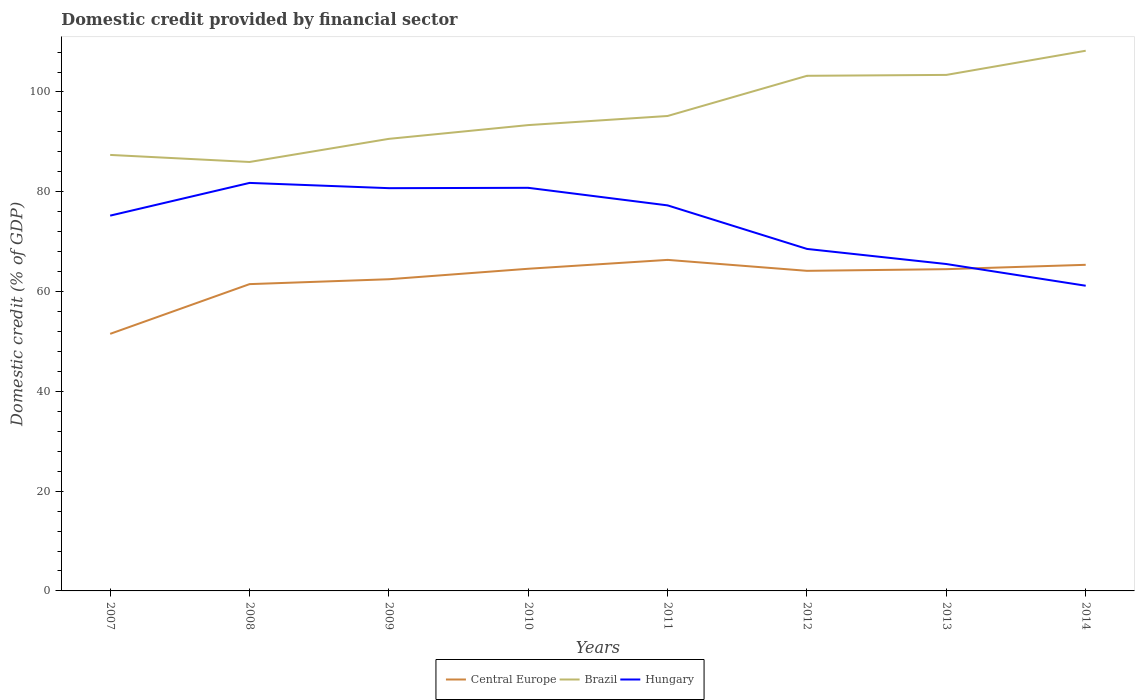How many different coloured lines are there?
Your answer should be very brief. 3. Does the line corresponding to Central Europe intersect with the line corresponding to Hungary?
Provide a succinct answer. Yes. Is the number of lines equal to the number of legend labels?
Give a very brief answer. Yes. Across all years, what is the maximum domestic credit in Brazil?
Offer a terse response. 85.97. What is the total domestic credit in Hungary in the graph?
Your answer should be very brief. 14.05. What is the difference between the highest and the second highest domestic credit in Hungary?
Keep it short and to the point. 20.61. What is the difference between the highest and the lowest domestic credit in Brazil?
Offer a very short reply. 3. Is the domestic credit in Brazil strictly greater than the domestic credit in Hungary over the years?
Keep it short and to the point. No. What is the difference between two consecutive major ticks on the Y-axis?
Your response must be concise. 20. Are the values on the major ticks of Y-axis written in scientific E-notation?
Give a very brief answer. No. Does the graph contain grids?
Your answer should be very brief. No. How many legend labels are there?
Offer a very short reply. 3. What is the title of the graph?
Give a very brief answer. Domestic credit provided by financial sector. What is the label or title of the Y-axis?
Make the answer very short. Domestic credit (% of GDP). What is the Domestic credit (% of GDP) of Central Europe in 2007?
Provide a succinct answer. 51.52. What is the Domestic credit (% of GDP) in Brazil in 2007?
Offer a very short reply. 87.39. What is the Domestic credit (% of GDP) in Hungary in 2007?
Offer a very short reply. 75.22. What is the Domestic credit (% of GDP) in Central Europe in 2008?
Offer a very short reply. 61.49. What is the Domestic credit (% of GDP) in Brazil in 2008?
Ensure brevity in your answer.  85.97. What is the Domestic credit (% of GDP) of Hungary in 2008?
Your answer should be compact. 81.78. What is the Domestic credit (% of GDP) in Central Europe in 2009?
Offer a very short reply. 62.47. What is the Domestic credit (% of GDP) in Brazil in 2009?
Offer a very short reply. 90.61. What is the Domestic credit (% of GDP) of Hungary in 2009?
Offer a very short reply. 80.72. What is the Domestic credit (% of GDP) of Central Europe in 2010?
Provide a succinct answer. 64.57. What is the Domestic credit (% of GDP) in Brazil in 2010?
Offer a very short reply. 93.36. What is the Domestic credit (% of GDP) of Hungary in 2010?
Give a very brief answer. 80.79. What is the Domestic credit (% of GDP) in Central Europe in 2011?
Your answer should be compact. 66.35. What is the Domestic credit (% of GDP) of Brazil in 2011?
Give a very brief answer. 95.19. What is the Domestic credit (% of GDP) of Hungary in 2011?
Your response must be concise. 77.27. What is the Domestic credit (% of GDP) of Central Europe in 2012?
Ensure brevity in your answer.  64.16. What is the Domestic credit (% of GDP) in Brazil in 2012?
Offer a very short reply. 103.24. What is the Domestic credit (% of GDP) in Hungary in 2012?
Your answer should be compact. 68.55. What is the Domestic credit (% of GDP) of Central Europe in 2013?
Offer a very short reply. 64.49. What is the Domestic credit (% of GDP) of Brazil in 2013?
Provide a short and direct response. 103.42. What is the Domestic credit (% of GDP) of Hungary in 2013?
Your response must be concise. 65.52. What is the Domestic credit (% of GDP) in Central Europe in 2014?
Your response must be concise. 65.36. What is the Domestic credit (% of GDP) in Brazil in 2014?
Your answer should be compact. 108.27. What is the Domestic credit (% of GDP) in Hungary in 2014?
Provide a succinct answer. 61.17. Across all years, what is the maximum Domestic credit (% of GDP) in Central Europe?
Keep it short and to the point. 66.35. Across all years, what is the maximum Domestic credit (% of GDP) of Brazil?
Your answer should be very brief. 108.27. Across all years, what is the maximum Domestic credit (% of GDP) of Hungary?
Ensure brevity in your answer.  81.78. Across all years, what is the minimum Domestic credit (% of GDP) in Central Europe?
Your response must be concise. 51.52. Across all years, what is the minimum Domestic credit (% of GDP) of Brazil?
Ensure brevity in your answer.  85.97. Across all years, what is the minimum Domestic credit (% of GDP) in Hungary?
Give a very brief answer. 61.17. What is the total Domestic credit (% of GDP) of Central Europe in the graph?
Give a very brief answer. 500.41. What is the total Domestic credit (% of GDP) of Brazil in the graph?
Your response must be concise. 767.46. What is the total Domestic credit (% of GDP) in Hungary in the graph?
Give a very brief answer. 591.01. What is the difference between the Domestic credit (% of GDP) in Central Europe in 2007 and that in 2008?
Ensure brevity in your answer.  -9.96. What is the difference between the Domestic credit (% of GDP) of Brazil in 2007 and that in 2008?
Make the answer very short. 1.42. What is the difference between the Domestic credit (% of GDP) of Hungary in 2007 and that in 2008?
Provide a succinct answer. -6.56. What is the difference between the Domestic credit (% of GDP) in Central Europe in 2007 and that in 2009?
Your answer should be very brief. -10.95. What is the difference between the Domestic credit (% of GDP) of Brazil in 2007 and that in 2009?
Your response must be concise. -3.22. What is the difference between the Domestic credit (% of GDP) in Hungary in 2007 and that in 2009?
Offer a terse response. -5.51. What is the difference between the Domestic credit (% of GDP) of Central Europe in 2007 and that in 2010?
Give a very brief answer. -13.05. What is the difference between the Domestic credit (% of GDP) in Brazil in 2007 and that in 2010?
Make the answer very short. -5.98. What is the difference between the Domestic credit (% of GDP) of Hungary in 2007 and that in 2010?
Ensure brevity in your answer.  -5.58. What is the difference between the Domestic credit (% of GDP) in Central Europe in 2007 and that in 2011?
Give a very brief answer. -14.82. What is the difference between the Domestic credit (% of GDP) in Brazil in 2007 and that in 2011?
Your answer should be compact. -7.8. What is the difference between the Domestic credit (% of GDP) in Hungary in 2007 and that in 2011?
Your answer should be compact. -2.05. What is the difference between the Domestic credit (% of GDP) in Central Europe in 2007 and that in 2012?
Provide a succinct answer. -12.63. What is the difference between the Domestic credit (% of GDP) in Brazil in 2007 and that in 2012?
Your answer should be very brief. -15.86. What is the difference between the Domestic credit (% of GDP) in Hungary in 2007 and that in 2012?
Provide a short and direct response. 6.67. What is the difference between the Domestic credit (% of GDP) of Central Europe in 2007 and that in 2013?
Your answer should be compact. -12.96. What is the difference between the Domestic credit (% of GDP) in Brazil in 2007 and that in 2013?
Make the answer very short. -16.04. What is the difference between the Domestic credit (% of GDP) in Hungary in 2007 and that in 2013?
Offer a very short reply. 9.7. What is the difference between the Domestic credit (% of GDP) of Central Europe in 2007 and that in 2014?
Ensure brevity in your answer.  -13.84. What is the difference between the Domestic credit (% of GDP) in Brazil in 2007 and that in 2014?
Provide a succinct answer. -20.88. What is the difference between the Domestic credit (% of GDP) of Hungary in 2007 and that in 2014?
Give a very brief answer. 14.05. What is the difference between the Domestic credit (% of GDP) in Central Europe in 2008 and that in 2009?
Your answer should be compact. -0.98. What is the difference between the Domestic credit (% of GDP) of Brazil in 2008 and that in 2009?
Your answer should be compact. -4.64. What is the difference between the Domestic credit (% of GDP) of Hungary in 2008 and that in 2009?
Your answer should be compact. 1.05. What is the difference between the Domestic credit (% of GDP) of Central Europe in 2008 and that in 2010?
Make the answer very short. -3.08. What is the difference between the Domestic credit (% of GDP) of Brazil in 2008 and that in 2010?
Ensure brevity in your answer.  -7.39. What is the difference between the Domestic credit (% of GDP) in Hungary in 2008 and that in 2010?
Your answer should be compact. 0.98. What is the difference between the Domestic credit (% of GDP) of Central Europe in 2008 and that in 2011?
Give a very brief answer. -4.86. What is the difference between the Domestic credit (% of GDP) in Brazil in 2008 and that in 2011?
Keep it short and to the point. -9.22. What is the difference between the Domestic credit (% of GDP) of Hungary in 2008 and that in 2011?
Ensure brevity in your answer.  4.5. What is the difference between the Domestic credit (% of GDP) of Central Europe in 2008 and that in 2012?
Give a very brief answer. -2.67. What is the difference between the Domestic credit (% of GDP) of Brazil in 2008 and that in 2012?
Offer a very short reply. -17.27. What is the difference between the Domestic credit (% of GDP) in Hungary in 2008 and that in 2012?
Your answer should be compact. 13.23. What is the difference between the Domestic credit (% of GDP) of Central Europe in 2008 and that in 2013?
Offer a very short reply. -3. What is the difference between the Domestic credit (% of GDP) in Brazil in 2008 and that in 2013?
Offer a terse response. -17.45. What is the difference between the Domestic credit (% of GDP) in Hungary in 2008 and that in 2013?
Offer a terse response. 16.26. What is the difference between the Domestic credit (% of GDP) of Central Europe in 2008 and that in 2014?
Your answer should be very brief. -3.87. What is the difference between the Domestic credit (% of GDP) of Brazil in 2008 and that in 2014?
Your answer should be very brief. -22.3. What is the difference between the Domestic credit (% of GDP) in Hungary in 2008 and that in 2014?
Keep it short and to the point. 20.61. What is the difference between the Domestic credit (% of GDP) in Central Europe in 2009 and that in 2010?
Keep it short and to the point. -2.1. What is the difference between the Domestic credit (% of GDP) of Brazil in 2009 and that in 2010?
Offer a very short reply. -2.76. What is the difference between the Domestic credit (% of GDP) of Hungary in 2009 and that in 2010?
Your answer should be compact. -0.07. What is the difference between the Domestic credit (% of GDP) of Central Europe in 2009 and that in 2011?
Ensure brevity in your answer.  -3.88. What is the difference between the Domestic credit (% of GDP) of Brazil in 2009 and that in 2011?
Make the answer very short. -4.58. What is the difference between the Domestic credit (% of GDP) of Hungary in 2009 and that in 2011?
Offer a very short reply. 3.45. What is the difference between the Domestic credit (% of GDP) of Central Europe in 2009 and that in 2012?
Ensure brevity in your answer.  -1.69. What is the difference between the Domestic credit (% of GDP) of Brazil in 2009 and that in 2012?
Provide a short and direct response. -12.64. What is the difference between the Domestic credit (% of GDP) of Hungary in 2009 and that in 2012?
Provide a short and direct response. 12.18. What is the difference between the Domestic credit (% of GDP) in Central Europe in 2009 and that in 2013?
Your answer should be compact. -2.02. What is the difference between the Domestic credit (% of GDP) in Brazil in 2009 and that in 2013?
Give a very brief answer. -12.81. What is the difference between the Domestic credit (% of GDP) in Hungary in 2009 and that in 2013?
Provide a short and direct response. 15.21. What is the difference between the Domestic credit (% of GDP) of Central Europe in 2009 and that in 2014?
Offer a terse response. -2.89. What is the difference between the Domestic credit (% of GDP) of Brazil in 2009 and that in 2014?
Your response must be concise. -17.66. What is the difference between the Domestic credit (% of GDP) of Hungary in 2009 and that in 2014?
Your response must be concise. 19.56. What is the difference between the Domestic credit (% of GDP) in Central Europe in 2010 and that in 2011?
Your response must be concise. -1.78. What is the difference between the Domestic credit (% of GDP) of Brazil in 2010 and that in 2011?
Your response must be concise. -1.83. What is the difference between the Domestic credit (% of GDP) in Hungary in 2010 and that in 2011?
Offer a terse response. 3.52. What is the difference between the Domestic credit (% of GDP) in Central Europe in 2010 and that in 2012?
Offer a terse response. 0.42. What is the difference between the Domestic credit (% of GDP) of Brazil in 2010 and that in 2012?
Offer a terse response. -9.88. What is the difference between the Domestic credit (% of GDP) of Hungary in 2010 and that in 2012?
Offer a terse response. 12.25. What is the difference between the Domestic credit (% of GDP) in Central Europe in 2010 and that in 2013?
Your answer should be very brief. 0.08. What is the difference between the Domestic credit (% of GDP) in Brazil in 2010 and that in 2013?
Your answer should be compact. -10.06. What is the difference between the Domestic credit (% of GDP) in Hungary in 2010 and that in 2013?
Ensure brevity in your answer.  15.27. What is the difference between the Domestic credit (% of GDP) in Central Europe in 2010 and that in 2014?
Keep it short and to the point. -0.79. What is the difference between the Domestic credit (% of GDP) in Brazil in 2010 and that in 2014?
Ensure brevity in your answer.  -14.9. What is the difference between the Domestic credit (% of GDP) of Hungary in 2010 and that in 2014?
Provide a short and direct response. 19.63. What is the difference between the Domestic credit (% of GDP) of Central Europe in 2011 and that in 2012?
Keep it short and to the point. 2.19. What is the difference between the Domestic credit (% of GDP) of Brazil in 2011 and that in 2012?
Offer a very short reply. -8.05. What is the difference between the Domestic credit (% of GDP) of Hungary in 2011 and that in 2012?
Ensure brevity in your answer.  8.73. What is the difference between the Domestic credit (% of GDP) of Central Europe in 2011 and that in 2013?
Your answer should be very brief. 1.86. What is the difference between the Domestic credit (% of GDP) in Brazil in 2011 and that in 2013?
Offer a very short reply. -8.23. What is the difference between the Domestic credit (% of GDP) of Hungary in 2011 and that in 2013?
Your response must be concise. 11.75. What is the difference between the Domestic credit (% of GDP) of Brazil in 2011 and that in 2014?
Make the answer very short. -13.08. What is the difference between the Domestic credit (% of GDP) of Hungary in 2011 and that in 2014?
Your response must be concise. 16.11. What is the difference between the Domestic credit (% of GDP) of Central Europe in 2012 and that in 2013?
Offer a very short reply. -0.33. What is the difference between the Domestic credit (% of GDP) in Brazil in 2012 and that in 2013?
Your answer should be very brief. -0.18. What is the difference between the Domestic credit (% of GDP) in Hungary in 2012 and that in 2013?
Offer a terse response. 3.03. What is the difference between the Domestic credit (% of GDP) in Central Europe in 2012 and that in 2014?
Make the answer very short. -1.21. What is the difference between the Domestic credit (% of GDP) in Brazil in 2012 and that in 2014?
Your response must be concise. -5.02. What is the difference between the Domestic credit (% of GDP) in Hungary in 2012 and that in 2014?
Your response must be concise. 7.38. What is the difference between the Domestic credit (% of GDP) in Central Europe in 2013 and that in 2014?
Your response must be concise. -0.87. What is the difference between the Domestic credit (% of GDP) in Brazil in 2013 and that in 2014?
Offer a very short reply. -4.85. What is the difference between the Domestic credit (% of GDP) of Hungary in 2013 and that in 2014?
Ensure brevity in your answer.  4.35. What is the difference between the Domestic credit (% of GDP) in Central Europe in 2007 and the Domestic credit (% of GDP) in Brazil in 2008?
Ensure brevity in your answer.  -34.45. What is the difference between the Domestic credit (% of GDP) of Central Europe in 2007 and the Domestic credit (% of GDP) of Hungary in 2008?
Offer a terse response. -30.25. What is the difference between the Domestic credit (% of GDP) in Brazil in 2007 and the Domestic credit (% of GDP) in Hungary in 2008?
Your response must be concise. 5.61. What is the difference between the Domestic credit (% of GDP) in Central Europe in 2007 and the Domestic credit (% of GDP) in Brazil in 2009?
Ensure brevity in your answer.  -39.08. What is the difference between the Domestic credit (% of GDP) of Central Europe in 2007 and the Domestic credit (% of GDP) of Hungary in 2009?
Your response must be concise. -29.2. What is the difference between the Domestic credit (% of GDP) in Brazil in 2007 and the Domestic credit (% of GDP) in Hungary in 2009?
Ensure brevity in your answer.  6.66. What is the difference between the Domestic credit (% of GDP) of Central Europe in 2007 and the Domestic credit (% of GDP) of Brazil in 2010?
Provide a succinct answer. -41.84. What is the difference between the Domestic credit (% of GDP) of Central Europe in 2007 and the Domestic credit (% of GDP) of Hungary in 2010?
Keep it short and to the point. -29.27. What is the difference between the Domestic credit (% of GDP) of Brazil in 2007 and the Domestic credit (% of GDP) of Hungary in 2010?
Your answer should be very brief. 6.59. What is the difference between the Domestic credit (% of GDP) in Central Europe in 2007 and the Domestic credit (% of GDP) in Brazil in 2011?
Ensure brevity in your answer.  -43.67. What is the difference between the Domestic credit (% of GDP) of Central Europe in 2007 and the Domestic credit (% of GDP) of Hungary in 2011?
Offer a very short reply. -25.75. What is the difference between the Domestic credit (% of GDP) of Brazil in 2007 and the Domestic credit (% of GDP) of Hungary in 2011?
Your response must be concise. 10.12. What is the difference between the Domestic credit (% of GDP) of Central Europe in 2007 and the Domestic credit (% of GDP) of Brazil in 2012?
Your response must be concise. -51.72. What is the difference between the Domestic credit (% of GDP) in Central Europe in 2007 and the Domestic credit (% of GDP) in Hungary in 2012?
Your answer should be very brief. -17.02. What is the difference between the Domestic credit (% of GDP) of Brazil in 2007 and the Domestic credit (% of GDP) of Hungary in 2012?
Provide a succinct answer. 18.84. What is the difference between the Domestic credit (% of GDP) in Central Europe in 2007 and the Domestic credit (% of GDP) in Brazil in 2013?
Offer a terse response. -51.9. What is the difference between the Domestic credit (% of GDP) of Central Europe in 2007 and the Domestic credit (% of GDP) of Hungary in 2013?
Your response must be concise. -13.99. What is the difference between the Domestic credit (% of GDP) of Brazil in 2007 and the Domestic credit (% of GDP) of Hungary in 2013?
Your response must be concise. 21.87. What is the difference between the Domestic credit (% of GDP) of Central Europe in 2007 and the Domestic credit (% of GDP) of Brazil in 2014?
Keep it short and to the point. -56.74. What is the difference between the Domestic credit (% of GDP) in Central Europe in 2007 and the Domestic credit (% of GDP) in Hungary in 2014?
Your response must be concise. -9.64. What is the difference between the Domestic credit (% of GDP) in Brazil in 2007 and the Domestic credit (% of GDP) in Hungary in 2014?
Keep it short and to the point. 26.22. What is the difference between the Domestic credit (% of GDP) in Central Europe in 2008 and the Domestic credit (% of GDP) in Brazil in 2009?
Your answer should be compact. -29.12. What is the difference between the Domestic credit (% of GDP) in Central Europe in 2008 and the Domestic credit (% of GDP) in Hungary in 2009?
Keep it short and to the point. -19.23. What is the difference between the Domestic credit (% of GDP) of Brazil in 2008 and the Domestic credit (% of GDP) of Hungary in 2009?
Make the answer very short. 5.25. What is the difference between the Domestic credit (% of GDP) of Central Europe in 2008 and the Domestic credit (% of GDP) of Brazil in 2010?
Make the answer very short. -31.88. What is the difference between the Domestic credit (% of GDP) of Central Europe in 2008 and the Domestic credit (% of GDP) of Hungary in 2010?
Give a very brief answer. -19.3. What is the difference between the Domestic credit (% of GDP) in Brazil in 2008 and the Domestic credit (% of GDP) in Hungary in 2010?
Your response must be concise. 5.18. What is the difference between the Domestic credit (% of GDP) in Central Europe in 2008 and the Domestic credit (% of GDP) in Brazil in 2011?
Give a very brief answer. -33.7. What is the difference between the Domestic credit (% of GDP) of Central Europe in 2008 and the Domestic credit (% of GDP) of Hungary in 2011?
Provide a succinct answer. -15.78. What is the difference between the Domestic credit (% of GDP) in Brazil in 2008 and the Domestic credit (% of GDP) in Hungary in 2011?
Keep it short and to the point. 8.7. What is the difference between the Domestic credit (% of GDP) in Central Europe in 2008 and the Domestic credit (% of GDP) in Brazil in 2012?
Make the answer very short. -41.76. What is the difference between the Domestic credit (% of GDP) of Central Europe in 2008 and the Domestic credit (% of GDP) of Hungary in 2012?
Provide a succinct answer. -7.06. What is the difference between the Domestic credit (% of GDP) in Brazil in 2008 and the Domestic credit (% of GDP) in Hungary in 2012?
Provide a short and direct response. 17.43. What is the difference between the Domestic credit (% of GDP) in Central Europe in 2008 and the Domestic credit (% of GDP) in Brazil in 2013?
Ensure brevity in your answer.  -41.93. What is the difference between the Domestic credit (% of GDP) in Central Europe in 2008 and the Domestic credit (% of GDP) in Hungary in 2013?
Offer a terse response. -4.03. What is the difference between the Domestic credit (% of GDP) in Brazil in 2008 and the Domestic credit (% of GDP) in Hungary in 2013?
Your response must be concise. 20.45. What is the difference between the Domestic credit (% of GDP) of Central Europe in 2008 and the Domestic credit (% of GDP) of Brazil in 2014?
Provide a short and direct response. -46.78. What is the difference between the Domestic credit (% of GDP) of Central Europe in 2008 and the Domestic credit (% of GDP) of Hungary in 2014?
Offer a very short reply. 0.32. What is the difference between the Domestic credit (% of GDP) of Brazil in 2008 and the Domestic credit (% of GDP) of Hungary in 2014?
Make the answer very short. 24.8. What is the difference between the Domestic credit (% of GDP) in Central Europe in 2009 and the Domestic credit (% of GDP) in Brazil in 2010?
Keep it short and to the point. -30.89. What is the difference between the Domestic credit (% of GDP) of Central Europe in 2009 and the Domestic credit (% of GDP) of Hungary in 2010?
Your answer should be very brief. -18.32. What is the difference between the Domestic credit (% of GDP) in Brazil in 2009 and the Domestic credit (% of GDP) in Hungary in 2010?
Your answer should be compact. 9.81. What is the difference between the Domestic credit (% of GDP) of Central Europe in 2009 and the Domestic credit (% of GDP) of Brazil in 2011?
Provide a short and direct response. -32.72. What is the difference between the Domestic credit (% of GDP) of Central Europe in 2009 and the Domestic credit (% of GDP) of Hungary in 2011?
Ensure brevity in your answer.  -14.8. What is the difference between the Domestic credit (% of GDP) of Brazil in 2009 and the Domestic credit (% of GDP) of Hungary in 2011?
Provide a succinct answer. 13.34. What is the difference between the Domestic credit (% of GDP) of Central Europe in 2009 and the Domestic credit (% of GDP) of Brazil in 2012?
Give a very brief answer. -40.77. What is the difference between the Domestic credit (% of GDP) in Central Europe in 2009 and the Domestic credit (% of GDP) in Hungary in 2012?
Offer a terse response. -6.08. What is the difference between the Domestic credit (% of GDP) of Brazil in 2009 and the Domestic credit (% of GDP) of Hungary in 2012?
Your answer should be compact. 22.06. What is the difference between the Domestic credit (% of GDP) of Central Europe in 2009 and the Domestic credit (% of GDP) of Brazil in 2013?
Your response must be concise. -40.95. What is the difference between the Domestic credit (% of GDP) in Central Europe in 2009 and the Domestic credit (% of GDP) in Hungary in 2013?
Your response must be concise. -3.05. What is the difference between the Domestic credit (% of GDP) of Brazil in 2009 and the Domestic credit (% of GDP) of Hungary in 2013?
Your answer should be very brief. 25.09. What is the difference between the Domestic credit (% of GDP) of Central Europe in 2009 and the Domestic credit (% of GDP) of Brazil in 2014?
Offer a very short reply. -45.8. What is the difference between the Domestic credit (% of GDP) of Central Europe in 2009 and the Domestic credit (% of GDP) of Hungary in 2014?
Make the answer very short. 1.3. What is the difference between the Domestic credit (% of GDP) of Brazil in 2009 and the Domestic credit (% of GDP) of Hungary in 2014?
Provide a short and direct response. 29.44. What is the difference between the Domestic credit (% of GDP) in Central Europe in 2010 and the Domestic credit (% of GDP) in Brazil in 2011?
Keep it short and to the point. -30.62. What is the difference between the Domestic credit (% of GDP) in Central Europe in 2010 and the Domestic credit (% of GDP) in Hungary in 2011?
Your answer should be very brief. -12.7. What is the difference between the Domestic credit (% of GDP) of Brazil in 2010 and the Domestic credit (% of GDP) of Hungary in 2011?
Keep it short and to the point. 16.09. What is the difference between the Domestic credit (% of GDP) in Central Europe in 2010 and the Domestic credit (% of GDP) in Brazil in 2012?
Keep it short and to the point. -38.67. What is the difference between the Domestic credit (% of GDP) in Central Europe in 2010 and the Domestic credit (% of GDP) in Hungary in 2012?
Keep it short and to the point. -3.97. What is the difference between the Domestic credit (% of GDP) of Brazil in 2010 and the Domestic credit (% of GDP) of Hungary in 2012?
Make the answer very short. 24.82. What is the difference between the Domestic credit (% of GDP) of Central Europe in 2010 and the Domestic credit (% of GDP) of Brazil in 2013?
Make the answer very short. -38.85. What is the difference between the Domestic credit (% of GDP) of Central Europe in 2010 and the Domestic credit (% of GDP) of Hungary in 2013?
Make the answer very short. -0.95. What is the difference between the Domestic credit (% of GDP) of Brazil in 2010 and the Domestic credit (% of GDP) of Hungary in 2013?
Your answer should be very brief. 27.85. What is the difference between the Domestic credit (% of GDP) in Central Europe in 2010 and the Domestic credit (% of GDP) in Brazil in 2014?
Your response must be concise. -43.7. What is the difference between the Domestic credit (% of GDP) in Central Europe in 2010 and the Domestic credit (% of GDP) in Hungary in 2014?
Offer a terse response. 3.4. What is the difference between the Domestic credit (% of GDP) of Brazil in 2010 and the Domestic credit (% of GDP) of Hungary in 2014?
Provide a succinct answer. 32.2. What is the difference between the Domestic credit (% of GDP) in Central Europe in 2011 and the Domestic credit (% of GDP) in Brazil in 2012?
Your response must be concise. -36.9. What is the difference between the Domestic credit (% of GDP) in Central Europe in 2011 and the Domestic credit (% of GDP) in Hungary in 2012?
Your answer should be very brief. -2.2. What is the difference between the Domestic credit (% of GDP) in Brazil in 2011 and the Domestic credit (% of GDP) in Hungary in 2012?
Offer a very short reply. 26.65. What is the difference between the Domestic credit (% of GDP) of Central Europe in 2011 and the Domestic credit (% of GDP) of Brazil in 2013?
Provide a short and direct response. -37.07. What is the difference between the Domestic credit (% of GDP) in Central Europe in 2011 and the Domestic credit (% of GDP) in Hungary in 2013?
Your answer should be very brief. 0.83. What is the difference between the Domestic credit (% of GDP) of Brazil in 2011 and the Domestic credit (% of GDP) of Hungary in 2013?
Make the answer very short. 29.67. What is the difference between the Domestic credit (% of GDP) in Central Europe in 2011 and the Domestic credit (% of GDP) in Brazil in 2014?
Offer a very short reply. -41.92. What is the difference between the Domestic credit (% of GDP) in Central Europe in 2011 and the Domestic credit (% of GDP) in Hungary in 2014?
Provide a succinct answer. 5.18. What is the difference between the Domestic credit (% of GDP) in Brazil in 2011 and the Domestic credit (% of GDP) in Hungary in 2014?
Offer a terse response. 34.02. What is the difference between the Domestic credit (% of GDP) of Central Europe in 2012 and the Domestic credit (% of GDP) of Brazil in 2013?
Ensure brevity in your answer.  -39.27. What is the difference between the Domestic credit (% of GDP) in Central Europe in 2012 and the Domestic credit (% of GDP) in Hungary in 2013?
Keep it short and to the point. -1.36. What is the difference between the Domestic credit (% of GDP) in Brazil in 2012 and the Domestic credit (% of GDP) in Hungary in 2013?
Give a very brief answer. 37.73. What is the difference between the Domestic credit (% of GDP) in Central Europe in 2012 and the Domestic credit (% of GDP) in Brazil in 2014?
Ensure brevity in your answer.  -44.11. What is the difference between the Domestic credit (% of GDP) in Central Europe in 2012 and the Domestic credit (% of GDP) in Hungary in 2014?
Offer a terse response. 2.99. What is the difference between the Domestic credit (% of GDP) of Brazil in 2012 and the Domestic credit (% of GDP) of Hungary in 2014?
Keep it short and to the point. 42.08. What is the difference between the Domestic credit (% of GDP) of Central Europe in 2013 and the Domestic credit (% of GDP) of Brazil in 2014?
Provide a short and direct response. -43.78. What is the difference between the Domestic credit (% of GDP) in Central Europe in 2013 and the Domestic credit (% of GDP) in Hungary in 2014?
Your answer should be very brief. 3.32. What is the difference between the Domestic credit (% of GDP) of Brazil in 2013 and the Domestic credit (% of GDP) of Hungary in 2014?
Give a very brief answer. 42.26. What is the average Domestic credit (% of GDP) in Central Europe per year?
Provide a succinct answer. 62.55. What is the average Domestic credit (% of GDP) of Brazil per year?
Your answer should be very brief. 95.93. What is the average Domestic credit (% of GDP) in Hungary per year?
Your answer should be compact. 73.88. In the year 2007, what is the difference between the Domestic credit (% of GDP) in Central Europe and Domestic credit (% of GDP) in Brazil?
Offer a very short reply. -35.86. In the year 2007, what is the difference between the Domestic credit (% of GDP) of Central Europe and Domestic credit (% of GDP) of Hungary?
Offer a very short reply. -23.69. In the year 2007, what is the difference between the Domestic credit (% of GDP) of Brazil and Domestic credit (% of GDP) of Hungary?
Keep it short and to the point. 12.17. In the year 2008, what is the difference between the Domestic credit (% of GDP) of Central Europe and Domestic credit (% of GDP) of Brazil?
Offer a terse response. -24.48. In the year 2008, what is the difference between the Domestic credit (% of GDP) of Central Europe and Domestic credit (% of GDP) of Hungary?
Provide a short and direct response. -20.29. In the year 2008, what is the difference between the Domestic credit (% of GDP) in Brazil and Domestic credit (% of GDP) in Hungary?
Provide a short and direct response. 4.2. In the year 2009, what is the difference between the Domestic credit (% of GDP) of Central Europe and Domestic credit (% of GDP) of Brazil?
Your response must be concise. -28.14. In the year 2009, what is the difference between the Domestic credit (% of GDP) of Central Europe and Domestic credit (% of GDP) of Hungary?
Provide a short and direct response. -18.25. In the year 2009, what is the difference between the Domestic credit (% of GDP) of Brazil and Domestic credit (% of GDP) of Hungary?
Offer a very short reply. 9.88. In the year 2010, what is the difference between the Domestic credit (% of GDP) of Central Europe and Domestic credit (% of GDP) of Brazil?
Provide a short and direct response. -28.79. In the year 2010, what is the difference between the Domestic credit (% of GDP) of Central Europe and Domestic credit (% of GDP) of Hungary?
Offer a very short reply. -16.22. In the year 2010, what is the difference between the Domestic credit (% of GDP) in Brazil and Domestic credit (% of GDP) in Hungary?
Offer a very short reply. 12.57. In the year 2011, what is the difference between the Domestic credit (% of GDP) in Central Europe and Domestic credit (% of GDP) in Brazil?
Your response must be concise. -28.84. In the year 2011, what is the difference between the Domestic credit (% of GDP) in Central Europe and Domestic credit (% of GDP) in Hungary?
Offer a terse response. -10.92. In the year 2011, what is the difference between the Domestic credit (% of GDP) in Brazil and Domestic credit (% of GDP) in Hungary?
Your answer should be very brief. 17.92. In the year 2012, what is the difference between the Domestic credit (% of GDP) of Central Europe and Domestic credit (% of GDP) of Brazil?
Offer a terse response. -39.09. In the year 2012, what is the difference between the Domestic credit (% of GDP) of Central Europe and Domestic credit (% of GDP) of Hungary?
Your answer should be compact. -4.39. In the year 2012, what is the difference between the Domestic credit (% of GDP) in Brazil and Domestic credit (% of GDP) in Hungary?
Offer a very short reply. 34.7. In the year 2013, what is the difference between the Domestic credit (% of GDP) in Central Europe and Domestic credit (% of GDP) in Brazil?
Your response must be concise. -38.94. In the year 2013, what is the difference between the Domestic credit (% of GDP) of Central Europe and Domestic credit (% of GDP) of Hungary?
Offer a terse response. -1.03. In the year 2013, what is the difference between the Domestic credit (% of GDP) of Brazil and Domestic credit (% of GDP) of Hungary?
Offer a very short reply. 37.9. In the year 2014, what is the difference between the Domestic credit (% of GDP) of Central Europe and Domestic credit (% of GDP) of Brazil?
Offer a terse response. -42.91. In the year 2014, what is the difference between the Domestic credit (% of GDP) of Central Europe and Domestic credit (% of GDP) of Hungary?
Keep it short and to the point. 4.19. In the year 2014, what is the difference between the Domestic credit (% of GDP) of Brazil and Domestic credit (% of GDP) of Hungary?
Offer a very short reply. 47.1. What is the ratio of the Domestic credit (% of GDP) of Central Europe in 2007 to that in 2008?
Offer a terse response. 0.84. What is the ratio of the Domestic credit (% of GDP) of Brazil in 2007 to that in 2008?
Offer a terse response. 1.02. What is the ratio of the Domestic credit (% of GDP) of Hungary in 2007 to that in 2008?
Your answer should be compact. 0.92. What is the ratio of the Domestic credit (% of GDP) in Central Europe in 2007 to that in 2009?
Provide a short and direct response. 0.82. What is the ratio of the Domestic credit (% of GDP) of Brazil in 2007 to that in 2009?
Offer a terse response. 0.96. What is the ratio of the Domestic credit (% of GDP) of Hungary in 2007 to that in 2009?
Keep it short and to the point. 0.93. What is the ratio of the Domestic credit (% of GDP) in Central Europe in 2007 to that in 2010?
Give a very brief answer. 0.8. What is the ratio of the Domestic credit (% of GDP) of Brazil in 2007 to that in 2010?
Make the answer very short. 0.94. What is the ratio of the Domestic credit (% of GDP) of Central Europe in 2007 to that in 2011?
Your response must be concise. 0.78. What is the ratio of the Domestic credit (% of GDP) of Brazil in 2007 to that in 2011?
Offer a very short reply. 0.92. What is the ratio of the Domestic credit (% of GDP) of Hungary in 2007 to that in 2011?
Offer a very short reply. 0.97. What is the ratio of the Domestic credit (% of GDP) of Central Europe in 2007 to that in 2012?
Your answer should be compact. 0.8. What is the ratio of the Domestic credit (% of GDP) of Brazil in 2007 to that in 2012?
Offer a very short reply. 0.85. What is the ratio of the Domestic credit (% of GDP) in Hungary in 2007 to that in 2012?
Offer a very short reply. 1.1. What is the ratio of the Domestic credit (% of GDP) of Central Europe in 2007 to that in 2013?
Ensure brevity in your answer.  0.8. What is the ratio of the Domestic credit (% of GDP) of Brazil in 2007 to that in 2013?
Your answer should be very brief. 0.84. What is the ratio of the Domestic credit (% of GDP) of Hungary in 2007 to that in 2013?
Keep it short and to the point. 1.15. What is the ratio of the Domestic credit (% of GDP) of Central Europe in 2007 to that in 2014?
Keep it short and to the point. 0.79. What is the ratio of the Domestic credit (% of GDP) in Brazil in 2007 to that in 2014?
Give a very brief answer. 0.81. What is the ratio of the Domestic credit (% of GDP) in Hungary in 2007 to that in 2014?
Keep it short and to the point. 1.23. What is the ratio of the Domestic credit (% of GDP) of Central Europe in 2008 to that in 2009?
Provide a short and direct response. 0.98. What is the ratio of the Domestic credit (% of GDP) of Brazil in 2008 to that in 2009?
Keep it short and to the point. 0.95. What is the ratio of the Domestic credit (% of GDP) of Central Europe in 2008 to that in 2010?
Ensure brevity in your answer.  0.95. What is the ratio of the Domestic credit (% of GDP) of Brazil in 2008 to that in 2010?
Offer a terse response. 0.92. What is the ratio of the Domestic credit (% of GDP) of Hungary in 2008 to that in 2010?
Provide a succinct answer. 1.01. What is the ratio of the Domestic credit (% of GDP) of Central Europe in 2008 to that in 2011?
Give a very brief answer. 0.93. What is the ratio of the Domestic credit (% of GDP) of Brazil in 2008 to that in 2011?
Ensure brevity in your answer.  0.9. What is the ratio of the Domestic credit (% of GDP) in Hungary in 2008 to that in 2011?
Offer a terse response. 1.06. What is the ratio of the Domestic credit (% of GDP) of Central Europe in 2008 to that in 2012?
Your answer should be compact. 0.96. What is the ratio of the Domestic credit (% of GDP) of Brazil in 2008 to that in 2012?
Provide a succinct answer. 0.83. What is the ratio of the Domestic credit (% of GDP) in Hungary in 2008 to that in 2012?
Offer a terse response. 1.19. What is the ratio of the Domestic credit (% of GDP) of Central Europe in 2008 to that in 2013?
Keep it short and to the point. 0.95. What is the ratio of the Domestic credit (% of GDP) in Brazil in 2008 to that in 2013?
Keep it short and to the point. 0.83. What is the ratio of the Domestic credit (% of GDP) in Hungary in 2008 to that in 2013?
Provide a short and direct response. 1.25. What is the ratio of the Domestic credit (% of GDP) in Central Europe in 2008 to that in 2014?
Keep it short and to the point. 0.94. What is the ratio of the Domestic credit (% of GDP) of Brazil in 2008 to that in 2014?
Provide a succinct answer. 0.79. What is the ratio of the Domestic credit (% of GDP) of Hungary in 2008 to that in 2014?
Your answer should be compact. 1.34. What is the ratio of the Domestic credit (% of GDP) of Central Europe in 2009 to that in 2010?
Ensure brevity in your answer.  0.97. What is the ratio of the Domestic credit (% of GDP) of Brazil in 2009 to that in 2010?
Provide a short and direct response. 0.97. What is the ratio of the Domestic credit (% of GDP) in Central Europe in 2009 to that in 2011?
Ensure brevity in your answer.  0.94. What is the ratio of the Domestic credit (% of GDP) of Brazil in 2009 to that in 2011?
Keep it short and to the point. 0.95. What is the ratio of the Domestic credit (% of GDP) in Hungary in 2009 to that in 2011?
Make the answer very short. 1.04. What is the ratio of the Domestic credit (% of GDP) of Central Europe in 2009 to that in 2012?
Offer a terse response. 0.97. What is the ratio of the Domestic credit (% of GDP) of Brazil in 2009 to that in 2012?
Provide a short and direct response. 0.88. What is the ratio of the Domestic credit (% of GDP) of Hungary in 2009 to that in 2012?
Your answer should be compact. 1.18. What is the ratio of the Domestic credit (% of GDP) of Central Europe in 2009 to that in 2013?
Your answer should be compact. 0.97. What is the ratio of the Domestic credit (% of GDP) of Brazil in 2009 to that in 2013?
Keep it short and to the point. 0.88. What is the ratio of the Domestic credit (% of GDP) in Hungary in 2009 to that in 2013?
Keep it short and to the point. 1.23. What is the ratio of the Domestic credit (% of GDP) of Central Europe in 2009 to that in 2014?
Your response must be concise. 0.96. What is the ratio of the Domestic credit (% of GDP) in Brazil in 2009 to that in 2014?
Make the answer very short. 0.84. What is the ratio of the Domestic credit (% of GDP) in Hungary in 2009 to that in 2014?
Make the answer very short. 1.32. What is the ratio of the Domestic credit (% of GDP) in Central Europe in 2010 to that in 2011?
Make the answer very short. 0.97. What is the ratio of the Domestic credit (% of GDP) of Brazil in 2010 to that in 2011?
Ensure brevity in your answer.  0.98. What is the ratio of the Domestic credit (% of GDP) of Hungary in 2010 to that in 2011?
Make the answer very short. 1.05. What is the ratio of the Domestic credit (% of GDP) in Central Europe in 2010 to that in 2012?
Ensure brevity in your answer.  1.01. What is the ratio of the Domestic credit (% of GDP) in Brazil in 2010 to that in 2012?
Your answer should be compact. 0.9. What is the ratio of the Domestic credit (% of GDP) of Hungary in 2010 to that in 2012?
Your answer should be compact. 1.18. What is the ratio of the Domestic credit (% of GDP) in Brazil in 2010 to that in 2013?
Your answer should be compact. 0.9. What is the ratio of the Domestic credit (% of GDP) of Hungary in 2010 to that in 2013?
Offer a terse response. 1.23. What is the ratio of the Domestic credit (% of GDP) in Central Europe in 2010 to that in 2014?
Give a very brief answer. 0.99. What is the ratio of the Domestic credit (% of GDP) in Brazil in 2010 to that in 2014?
Your answer should be compact. 0.86. What is the ratio of the Domestic credit (% of GDP) in Hungary in 2010 to that in 2014?
Your answer should be very brief. 1.32. What is the ratio of the Domestic credit (% of GDP) of Central Europe in 2011 to that in 2012?
Give a very brief answer. 1.03. What is the ratio of the Domestic credit (% of GDP) of Brazil in 2011 to that in 2012?
Your response must be concise. 0.92. What is the ratio of the Domestic credit (% of GDP) in Hungary in 2011 to that in 2012?
Offer a terse response. 1.13. What is the ratio of the Domestic credit (% of GDP) of Central Europe in 2011 to that in 2013?
Make the answer very short. 1.03. What is the ratio of the Domestic credit (% of GDP) in Brazil in 2011 to that in 2013?
Make the answer very short. 0.92. What is the ratio of the Domestic credit (% of GDP) of Hungary in 2011 to that in 2013?
Provide a succinct answer. 1.18. What is the ratio of the Domestic credit (% of GDP) in Central Europe in 2011 to that in 2014?
Your response must be concise. 1.02. What is the ratio of the Domestic credit (% of GDP) of Brazil in 2011 to that in 2014?
Ensure brevity in your answer.  0.88. What is the ratio of the Domestic credit (% of GDP) of Hungary in 2011 to that in 2014?
Give a very brief answer. 1.26. What is the ratio of the Domestic credit (% of GDP) of Central Europe in 2012 to that in 2013?
Offer a very short reply. 0.99. What is the ratio of the Domestic credit (% of GDP) in Brazil in 2012 to that in 2013?
Your answer should be compact. 1. What is the ratio of the Domestic credit (% of GDP) of Hungary in 2012 to that in 2013?
Your answer should be compact. 1.05. What is the ratio of the Domestic credit (% of GDP) in Central Europe in 2012 to that in 2014?
Provide a succinct answer. 0.98. What is the ratio of the Domestic credit (% of GDP) in Brazil in 2012 to that in 2014?
Offer a terse response. 0.95. What is the ratio of the Domestic credit (% of GDP) of Hungary in 2012 to that in 2014?
Offer a very short reply. 1.12. What is the ratio of the Domestic credit (% of GDP) in Central Europe in 2013 to that in 2014?
Provide a short and direct response. 0.99. What is the ratio of the Domestic credit (% of GDP) in Brazil in 2013 to that in 2014?
Provide a short and direct response. 0.96. What is the ratio of the Domestic credit (% of GDP) of Hungary in 2013 to that in 2014?
Your response must be concise. 1.07. What is the difference between the highest and the second highest Domestic credit (% of GDP) in Brazil?
Your response must be concise. 4.85. What is the difference between the highest and the second highest Domestic credit (% of GDP) of Hungary?
Keep it short and to the point. 0.98. What is the difference between the highest and the lowest Domestic credit (% of GDP) in Central Europe?
Offer a terse response. 14.82. What is the difference between the highest and the lowest Domestic credit (% of GDP) of Brazil?
Keep it short and to the point. 22.3. What is the difference between the highest and the lowest Domestic credit (% of GDP) in Hungary?
Your answer should be compact. 20.61. 